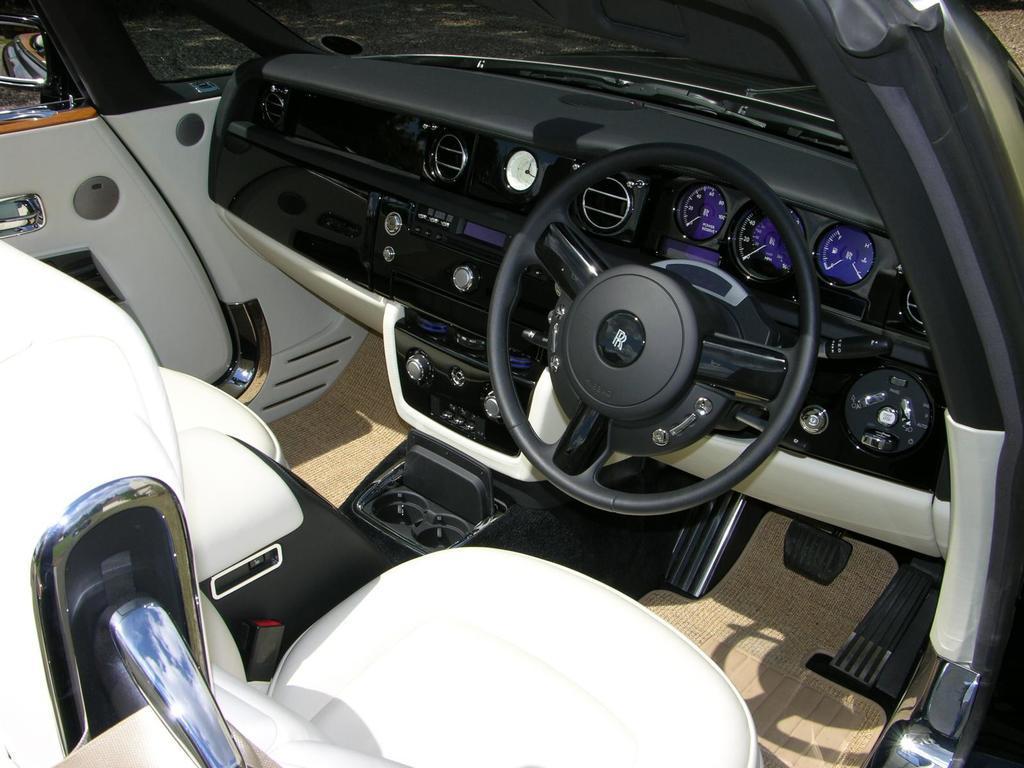Can you describe this image briefly? In the image we can see inside of the image vehicle. 